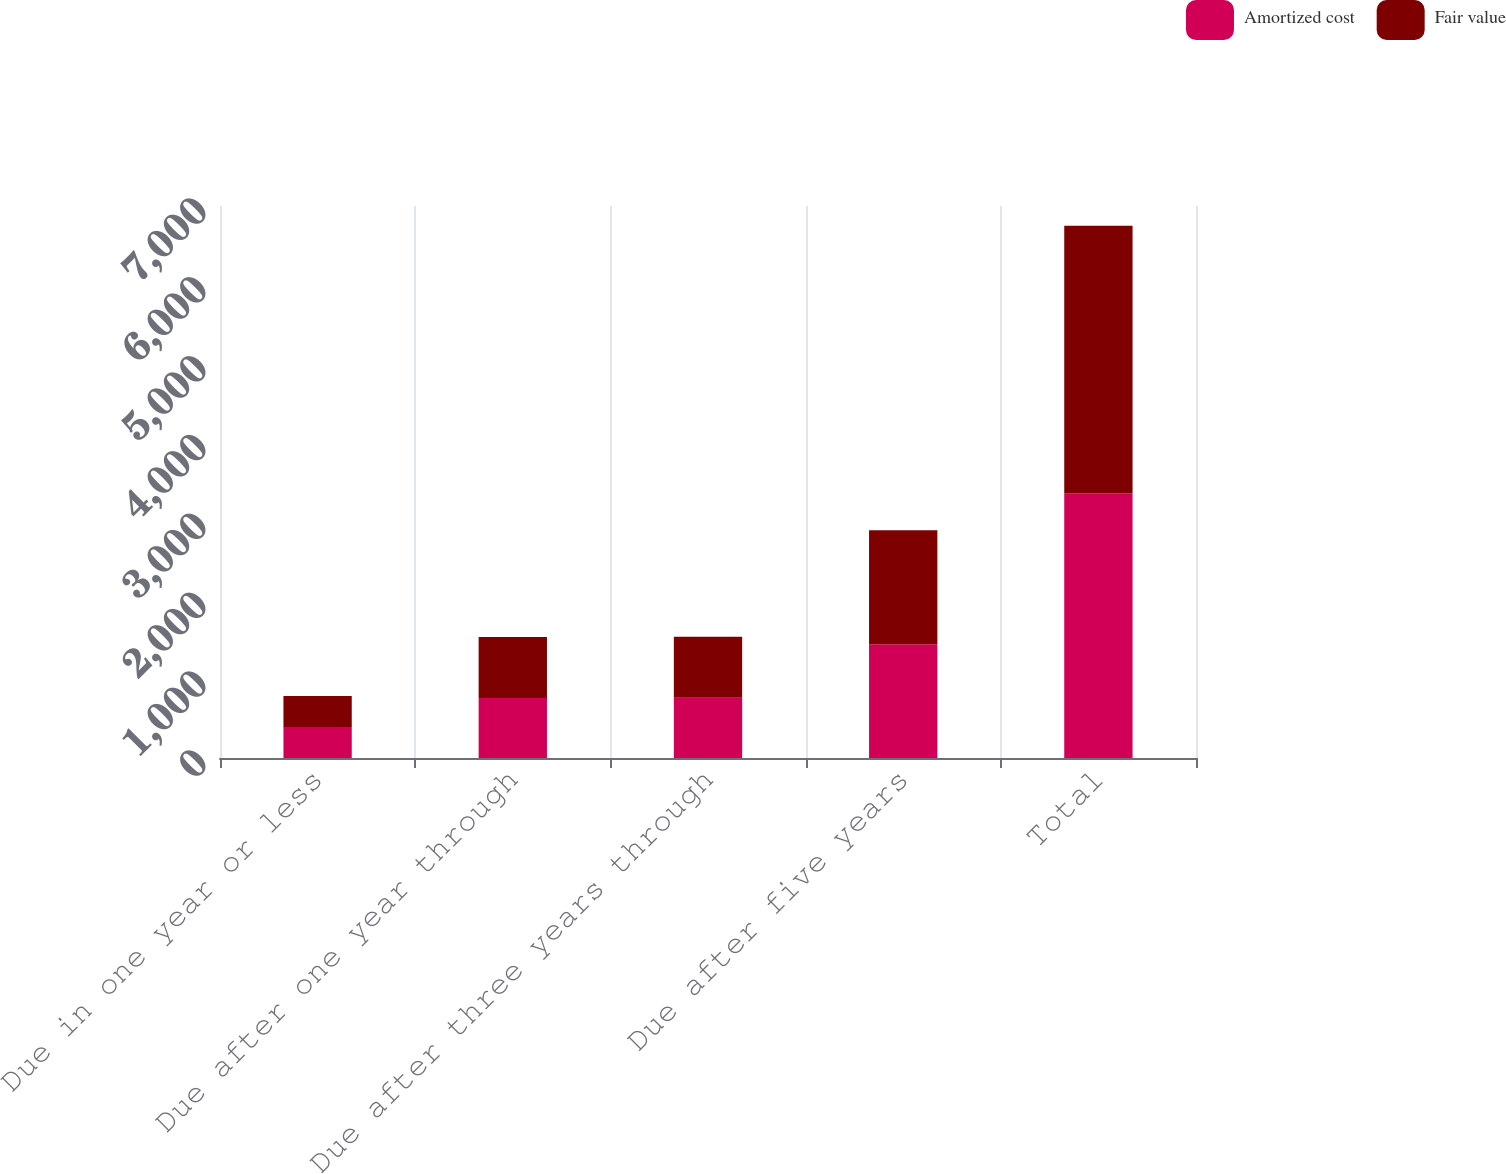Convert chart to OTSL. <chart><loc_0><loc_0><loc_500><loc_500><stacked_bar_chart><ecel><fcel>Due in one year or less<fcel>Due after one year through<fcel>Due after three years through<fcel>Due after five years<fcel>Total<nl><fcel>Amortized cost<fcel>392<fcel>759.8<fcel>764.1<fcel>1441<fcel>3356.9<nl><fcel>Fair value<fcel>394.3<fcel>776<fcel>774.3<fcel>1446.8<fcel>3391.4<nl></chart> 